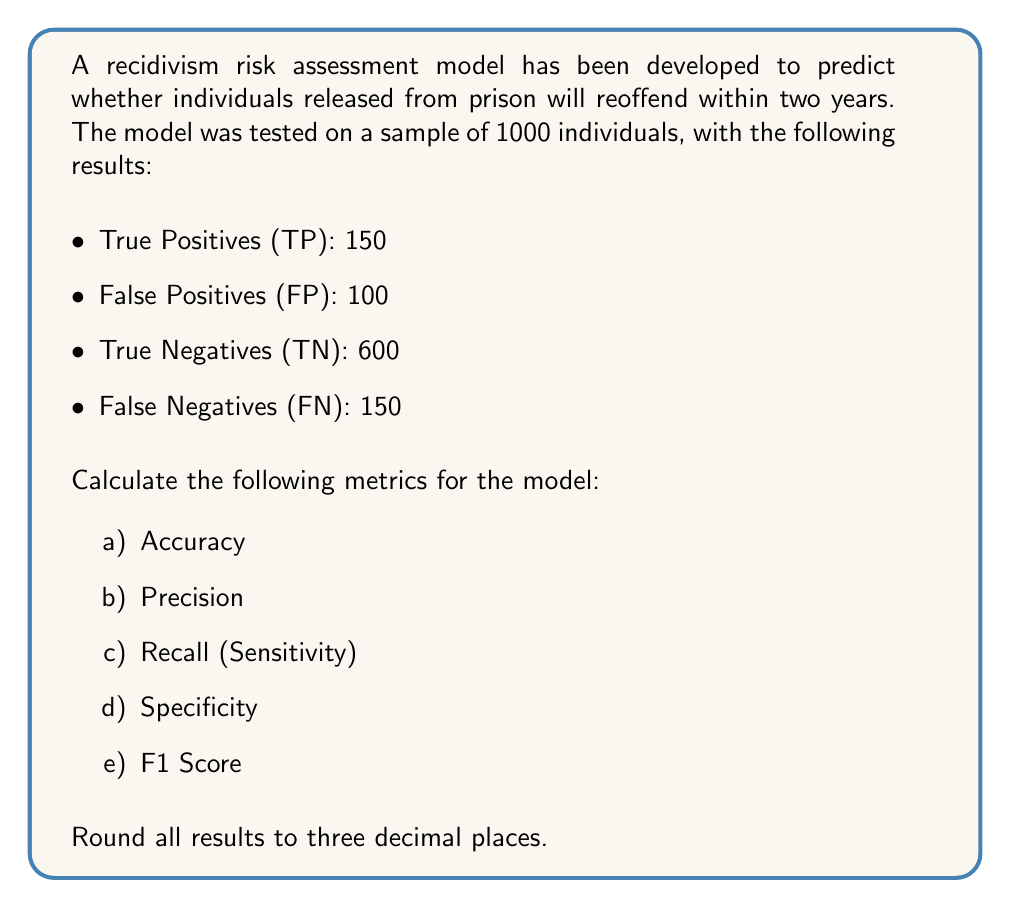Provide a solution to this math problem. To calculate the prediction accuracy and error rates for the recidivism risk assessment model, we'll use the given confusion matrix values:

TP = 150, FP = 100, TN = 600, FN = 150

Let's calculate each metric step by step:

a) Accuracy:
Accuracy measures the overall correctness of the model.
$$ \text{Accuracy} = \frac{\text{TP} + \text{TN}}{\text{TP} + \text{TN} + \text{FP} + \text{FN}} $$
$$ \text{Accuracy} = \frac{150 + 600}{150 + 600 + 100 + 150} = \frac{750}{1000} = 0.750 $$

b) Precision:
Precision measures the accuracy of positive predictions.
$$ \text{Precision} = \frac{\text{TP}}{\text{TP} + \text{FP}} $$
$$ \text{Precision} = \frac{150}{150 + 100} = \frac{150}{250} = 0.600 $$

c) Recall (Sensitivity):
Recall measures the proportion of actual positive cases correctly identified.
$$ \text{Recall} = \frac{\text{TP}}{\text{TP} + \text{FN}} $$
$$ \text{Recall} = \frac{150}{150 + 150} = \frac{150}{300} = 0.500 $$

d) Specificity:
Specificity measures the proportion of actual negative cases correctly identified.
$$ \text{Specificity} = \frac{\text{TN}}{\text{TN} + \text{FP}} $$
$$ \text{Specificity} = \frac{600}{600 + 100} = \frac{600}{700} \approx 0.857 $$

e) F1 Score:
The F1 Score is the harmonic mean of precision and recall, providing a balanced measure of the model's performance.
$$ \text{F1 Score} = 2 \times \frac{\text{Precision} \times \text{Recall}}{\text{Precision} + \text{Recall}} $$
$$ \text{F1 Score} = 2 \times \frac{0.600 \times 0.500}{0.600 + 0.500} \approx 0.545 $$
Answer: a) Accuracy: 0.750
b) Precision: 0.600
c) Recall (Sensitivity): 0.500
d) Specificity: 0.857
e) F1 Score: 0.545 